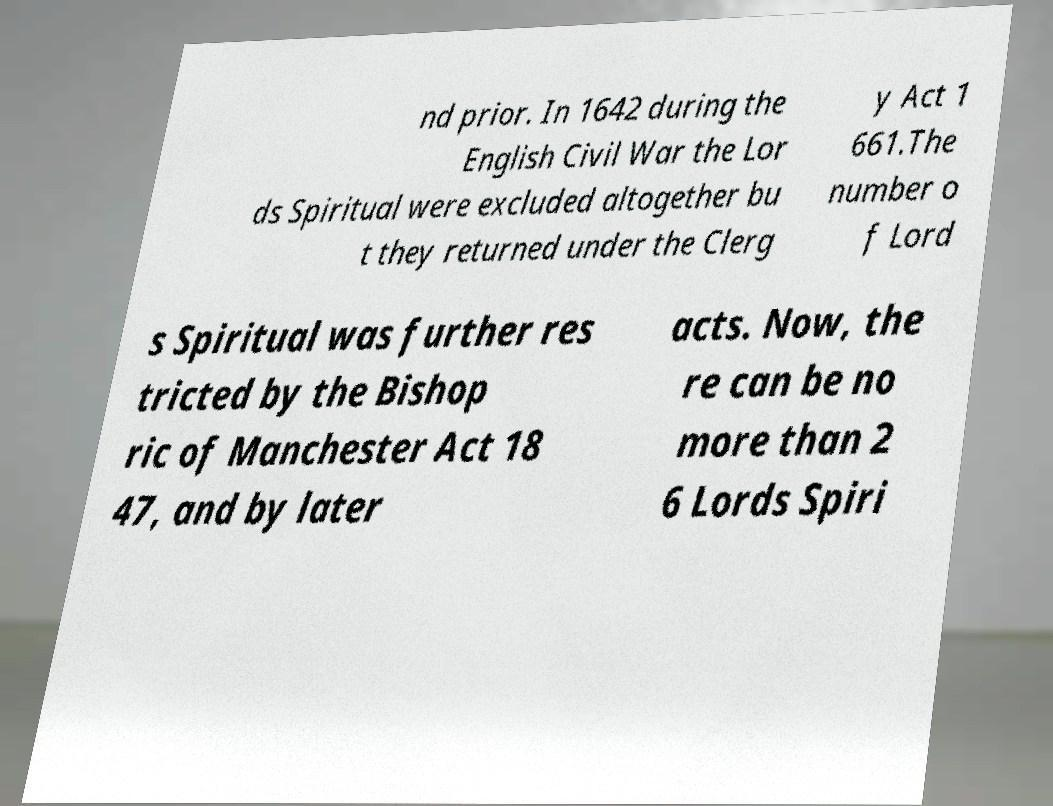Can you read and provide the text displayed in the image?This photo seems to have some interesting text. Can you extract and type it out for me? nd prior. In 1642 during the English Civil War the Lor ds Spiritual were excluded altogether bu t they returned under the Clerg y Act 1 661.The number o f Lord s Spiritual was further res tricted by the Bishop ric of Manchester Act 18 47, and by later acts. Now, the re can be no more than 2 6 Lords Spiri 